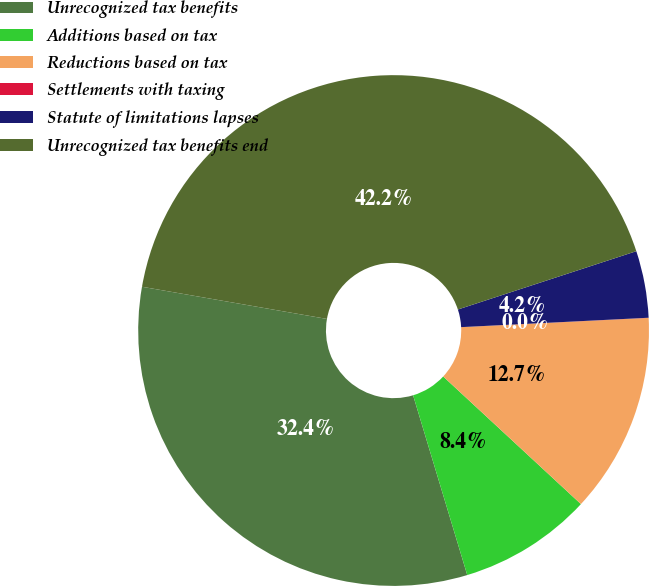<chart> <loc_0><loc_0><loc_500><loc_500><pie_chart><fcel>Unrecognized tax benefits<fcel>Additions based on tax<fcel>Reductions based on tax<fcel>Settlements with taxing<fcel>Statute of limitations lapses<fcel>Unrecognized tax benefits end<nl><fcel>32.4%<fcel>8.45%<fcel>12.68%<fcel>0.01%<fcel>4.23%<fcel>42.23%<nl></chart> 